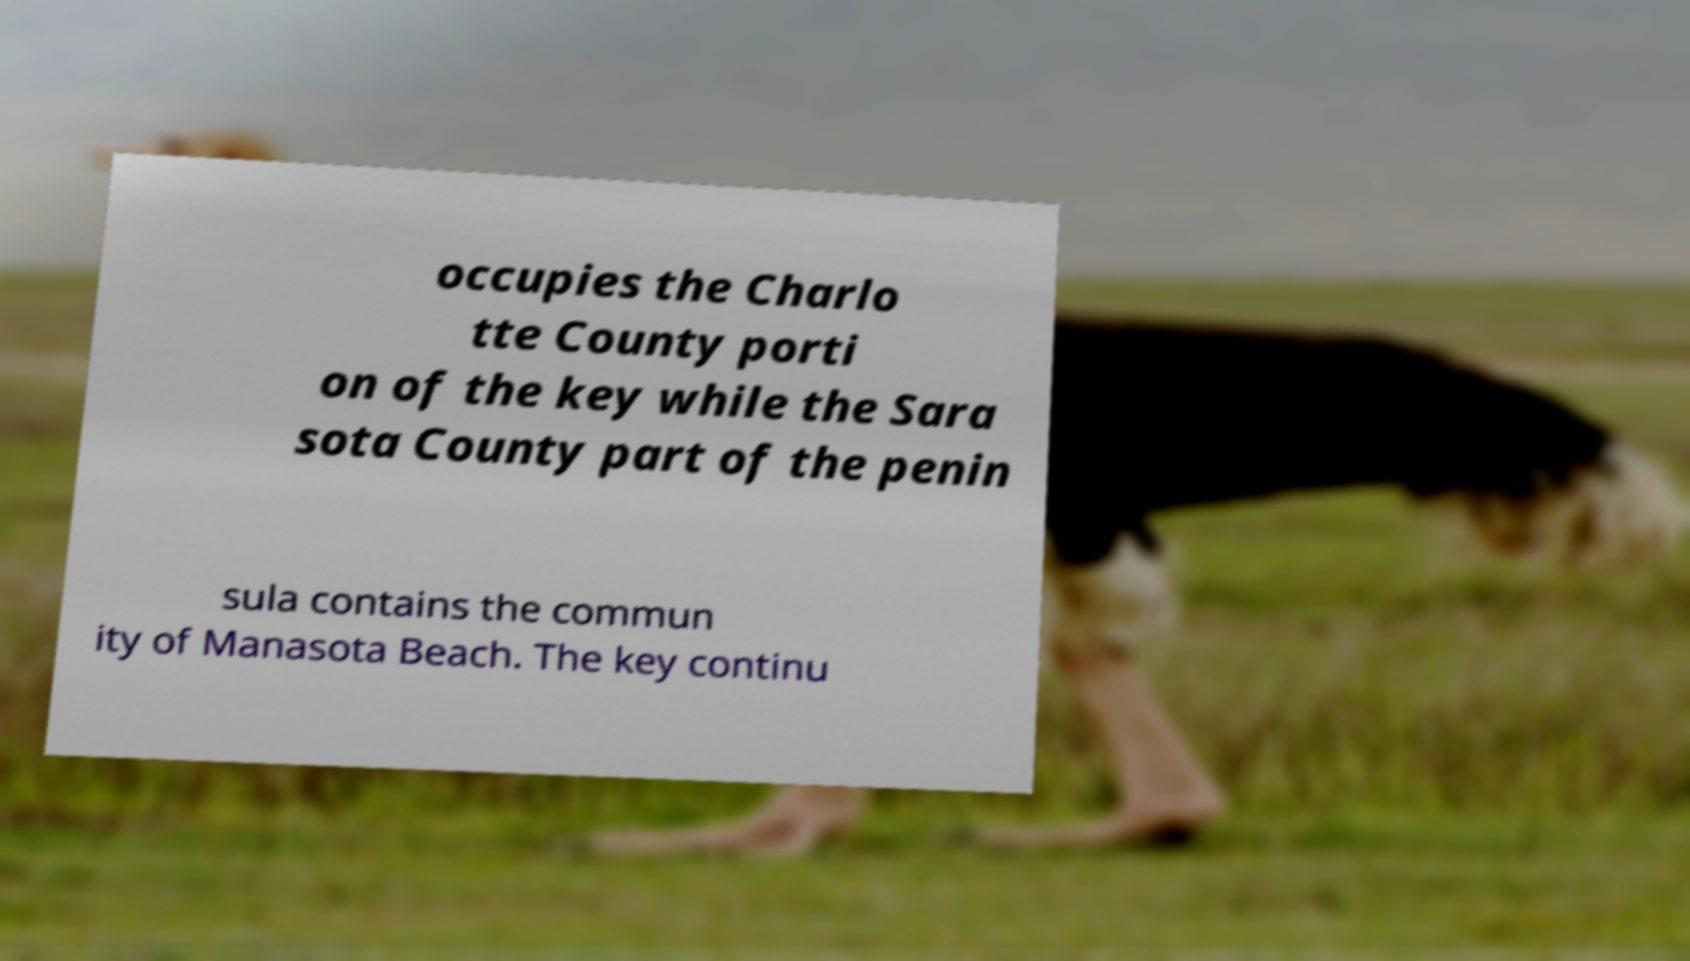There's text embedded in this image that I need extracted. Can you transcribe it verbatim? occupies the Charlo tte County porti on of the key while the Sara sota County part of the penin sula contains the commun ity of Manasota Beach. The key continu 